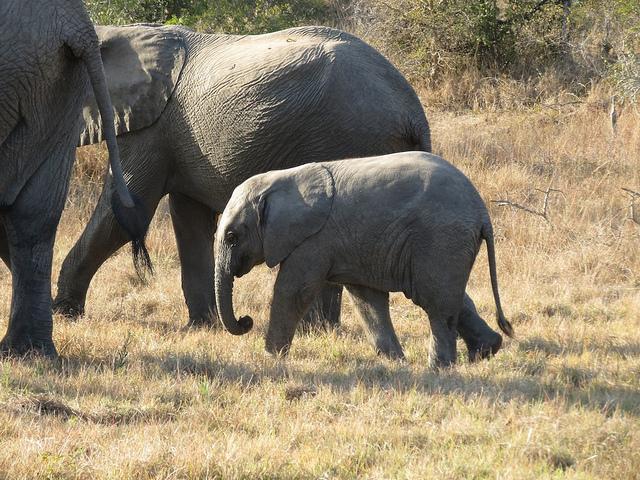How many elephants are there?
Give a very brief answer. 3. How many people are playing ball?
Give a very brief answer. 0. 